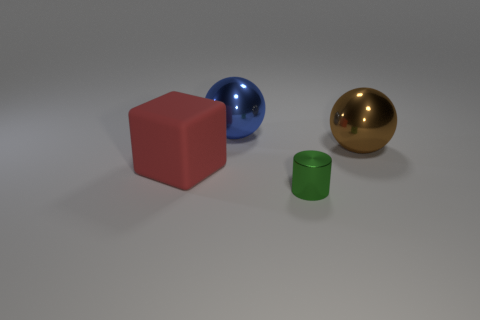Is there any other thing that has the same shape as the small object?
Ensure brevity in your answer.  No. Is there anything else that is the same size as the green cylinder?
Your answer should be very brief. No. How many other things are there of the same color as the block?
Provide a succinct answer. 0. How many spheres are purple rubber objects or large blue metallic things?
Your response must be concise. 1. What color is the metallic sphere to the right of the shiny thing in front of the matte thing?
Your response must be concise. Brown. What is the shape of the large brown object?
Offer a terse response. Sphere. There is a metallic object right of the green shiny thing; is its size the same as the red thing?
Ensure brevity in your answer.  Yes. Are there any brown things that have the same material as the big blue object?
Make the answer very short. Yes. How many things are objects behind the green cylinder or red matte things?
Your response must be concise. 3. Is there a big brown metallic thing?
Offer a very short reply. Yes. 